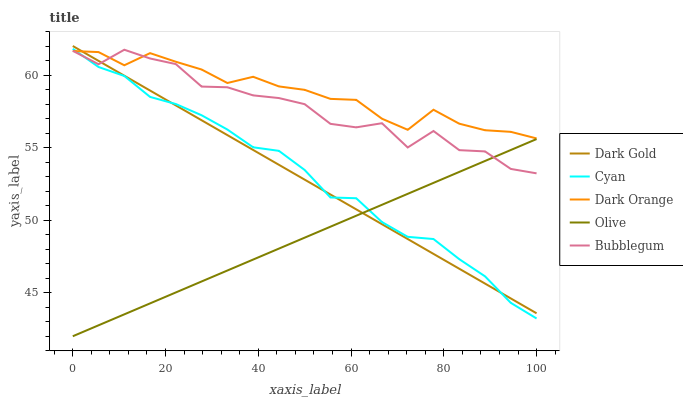Does Olive have the minimum area under the curve?
Answer yes or no. Yes. Does Dark Orange have the maximum area under the curve?
Answer yes or no. Yes. Does Cyan have the minimum area under the curve?
Answer yes or no. No. Does Cyan have the maximum area under the curve?
Answer yes or no. No. Is Olive the smoothest?
Answer yes or no. Yes. Is Bubblegum the roughest?
Answer yes or no. Yes. Is Cyan the smoothest?
Answer yes or no. No. Is Cyan the roughest?
Answer yes or no. No. Does Cyan have the lowest value?
Answer yes or no. No. Does Cyan have the highest value?
Answer yes or no. No. Is Olive less than Dark Orange?
Answer yes or no. Yes. Is Dark Orange greater than Olive?
Answer yes or no. Yes. Does Olive intersect Dark Orange?
Answer yes or no. No. 